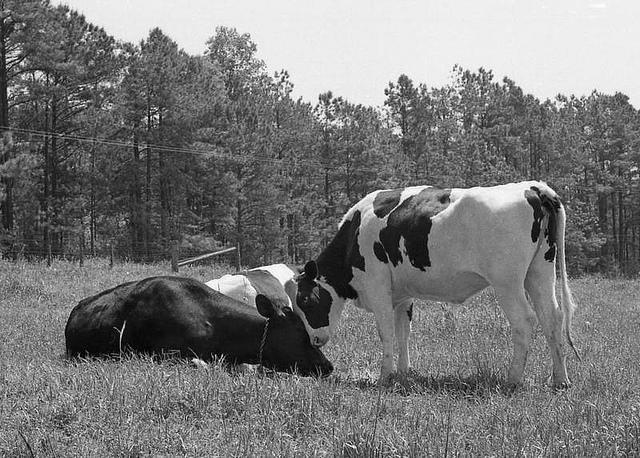How many cows in the picture?
Give a very brief answer. 3. How many cows are there?
Give a very brief answer. 3. 